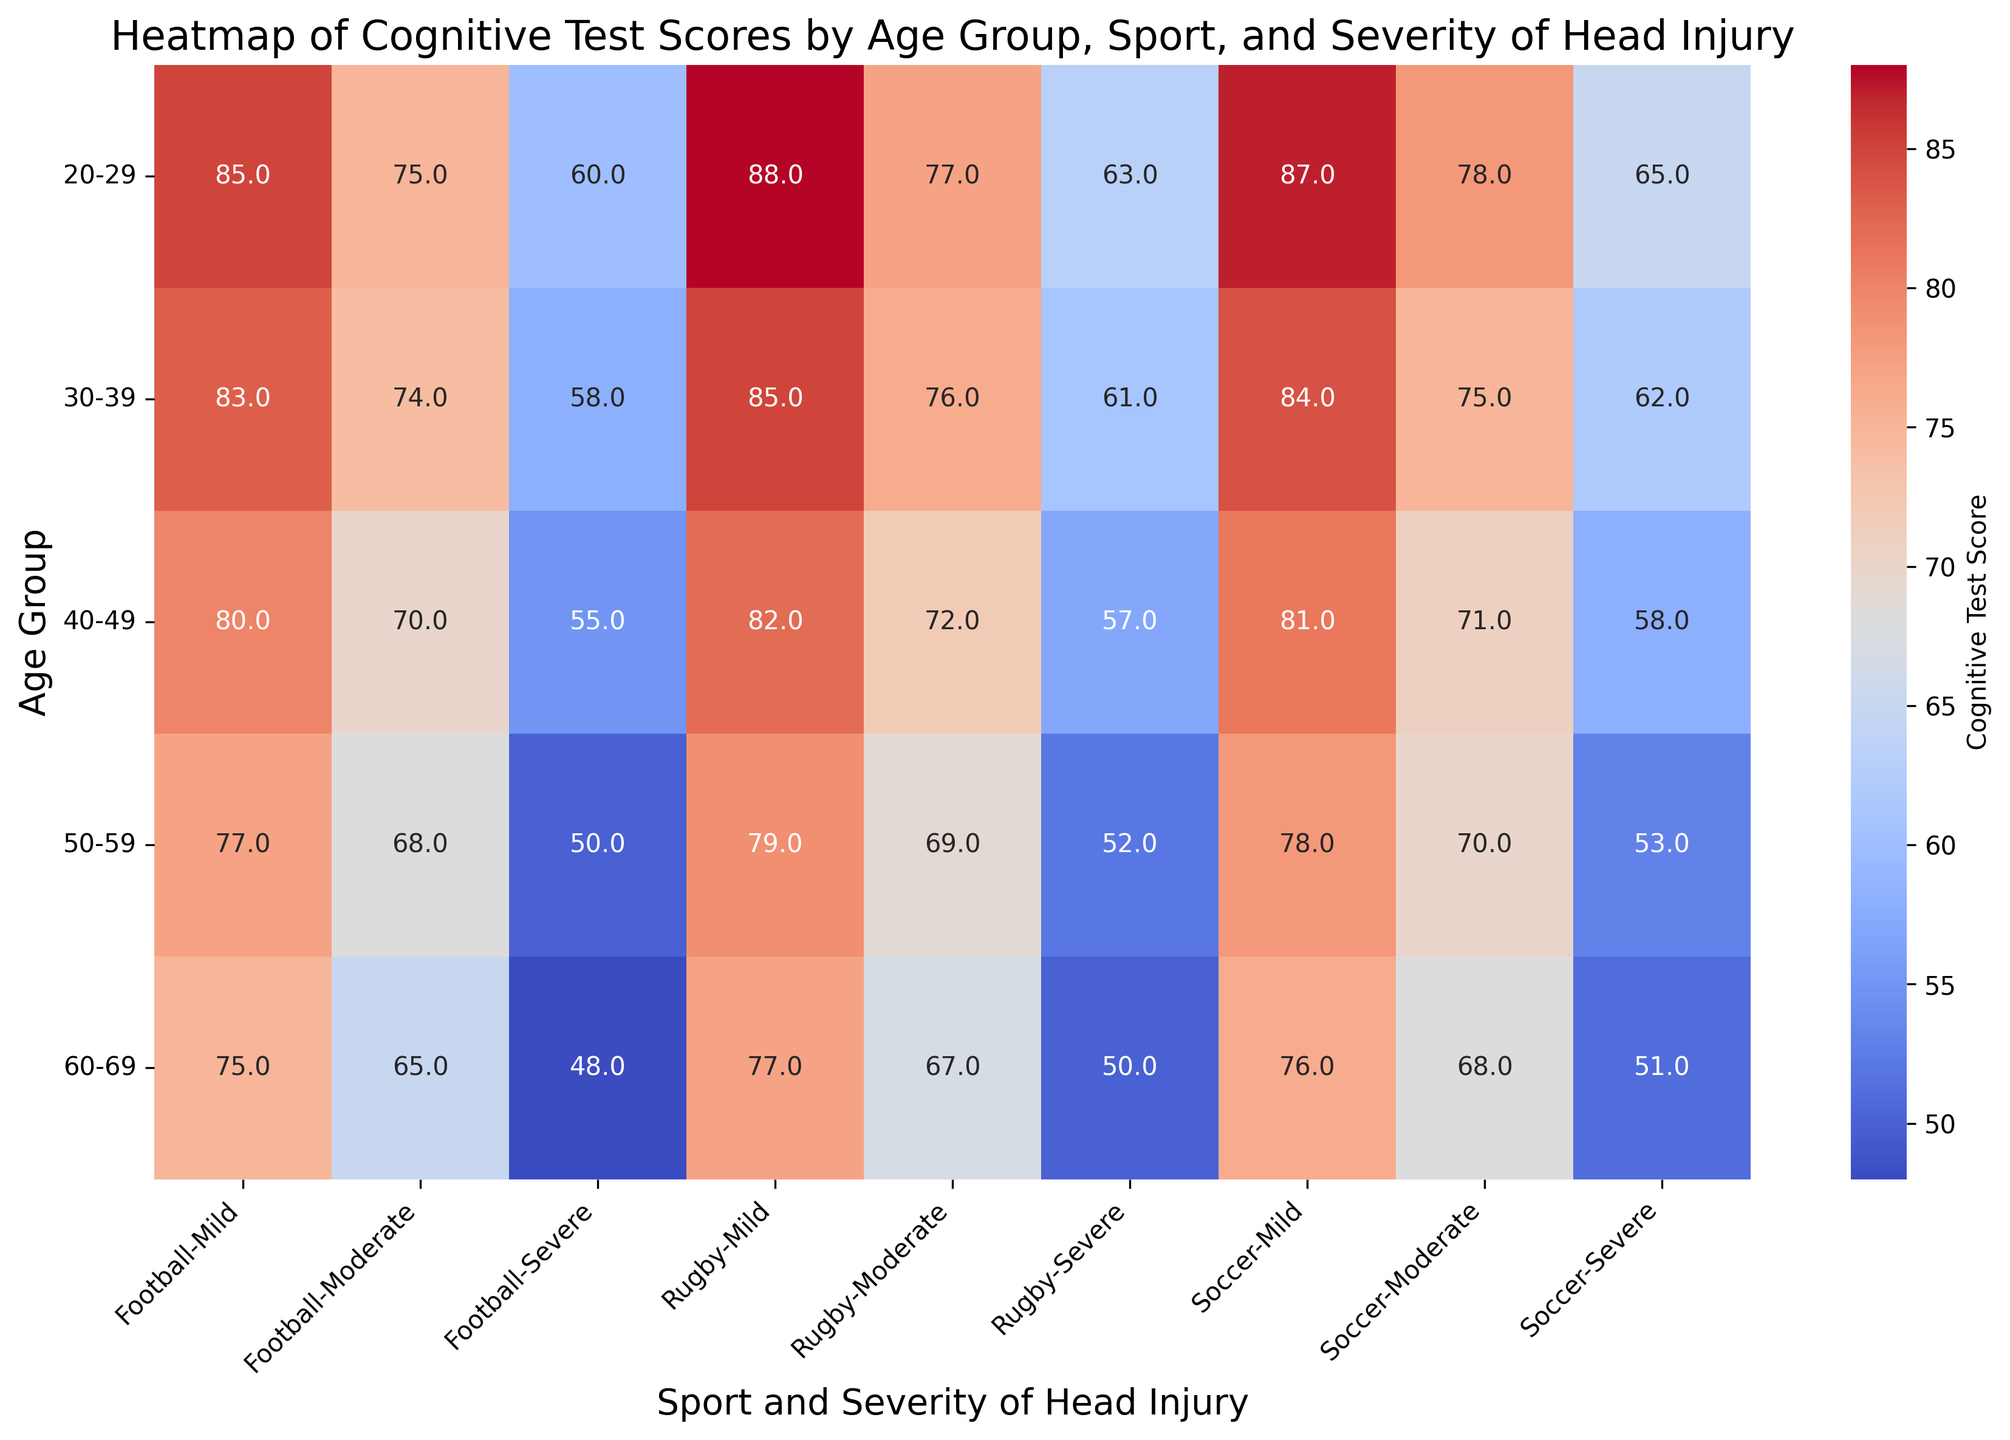What's the cognitive test score for 30-39-year-olds playing Soccer with severe head injuries? Locate the cell at the intersection of the row for the 30-39 age group and the column for Soccer with severe head injuries. The annotated value there is the cognitive test score.
Answer: 62 How do cognitive test scores of 20-29-year-olds playing Rugby with mild head injuries compare to those playing Soccer with severe head injuries? Find the cognitive test scores for 20-29-year-olds playing Rugby with mild injuries and Soccer with severe injuries. Rugby (mild) has 88, and Soccer (severe) has 65; compare these values.
Answer: 88 is greater than 65 What's the average cognitive test score for 50-59-year-olds with moderate head injuries across all sports? For the 50-59 age group, find the cognitive test scores for moderate injuries in Football, Rugby, and Soccer: 68, 69, and 70. Calculate their average by summing these values and dividing by 3: (68 + 69 + 70) / 3.
Answer: 69 Which sport and severity combination has the lowest cognitive test score in the 60-69 age group? For the 60-69 age group, examine the cognitive test scores for all combinations of sports and severity: Football (48), Rugby (50), and Soccer (51). Identify the lowest value and its corresponding category.
Answer: Football, Severe Are there any age groups where cognitive test scores remain stable across varying severities of head injuries? Review the cognitive test scores for each age group and check if the scores for mild, moderate, and severe injuries are identical or nearly identical in Football, Rugby, and Soccer.
Answer: No, scores vary across severities Which age group has the highest cognitive test score for mild head injuries in Soccer? Look at cognitive test scores for mild head injuries in Soccer across all age groups. Find the highest value among them.
Answer: 20-29 age group What is the difference in cognitive test scores between 40-49-year-olds and 50-59-year-olds with severe head injuries in Rugby? Locate the scores for severe head injuries in Rugby for both age groups: 40-49 (57) and 50-59 (52). Subtract the lower score from the higher score: 57 - 52.
Answer: 5 Which age group has the most significant drop in cognitive test scores as head injury severity increases in Football? Calculate the differences between cognitive test scores for mild and severe injuries across all age groups in Football. Identify the age group with the largest difference.
Answer: 50-59 age group What trend do you observe in cognitive test scores for Soccer players as they age, considering severe head injuries? Follow the scores for severe injuries in Soccer from the youngest (20-29) to the oldest (60-69): 65, 62, 58, 53, and 51. Note how scores generally decrease as the age group progresses.
Answer: Scores decrease with age How do cognitive test scores differ between mild head injuries in younger (20-29) vs. older (60-69) athletes playing Rugby? Compare the cognitive test scores for mild head injuries in Rugby between 20-29 (88) and 60-69 (77). Calculate the difference: 88 - 77.
Answer: 11 